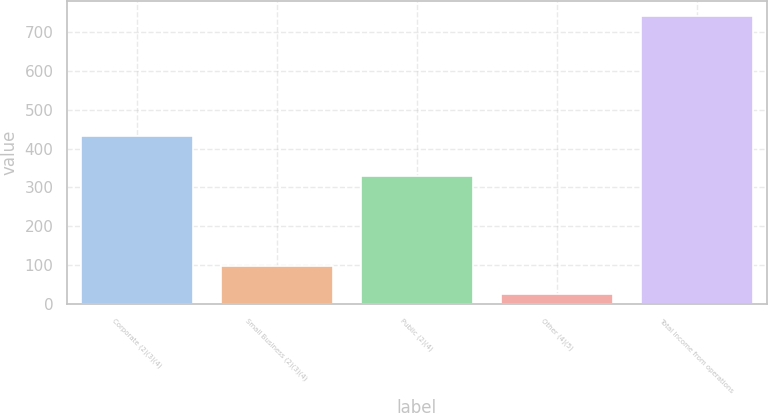Convert chart to OTSL. <chart><loc_0><loc_0><loc_500><loc_500><bar_chart><fcel>Corporate (2)(3)(4)<fcel>Small Business (2)(3)(4)<fcel>Public (2)(4)<fcel>Other (4)(5)<fcel>Total Income from operations<nl><fcel>432.5<fcel>98.59<fcel>328.6<fcel>27.1<fcel>742<nl></chart> 